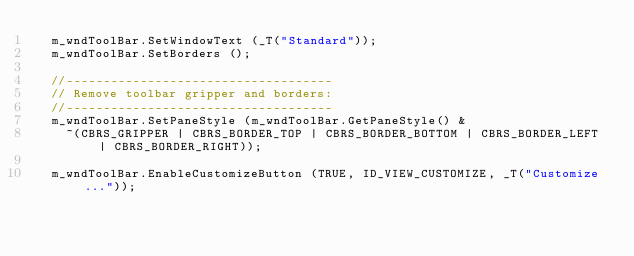<code> <loc_0><loc_0><loc_500><loc_500><_C++_>	m_wndToolBar.SetWindowText (_T("Standard"));
	m_wndToolBar.SetBorders ();

	//------------------------------------
	// Remove toolbar gripper and borders:
	//------------------------------------
	m_wndToolBar.SetPaneStyle (m_wndToolBar.GetPaneStyle() &
		~(CBRS_GRIPPER | CBRS_BORDER_TOP | CBRS_BORDER_BOTTOM | CBRS_BORDER_LEFT | CBRS_BORDER_RIGHT));

	m_wndToolBar.EnableCustomizeButton (TRUE, ID_VIEW_CUSTOMIZE, _T("Customize..."));</code> 